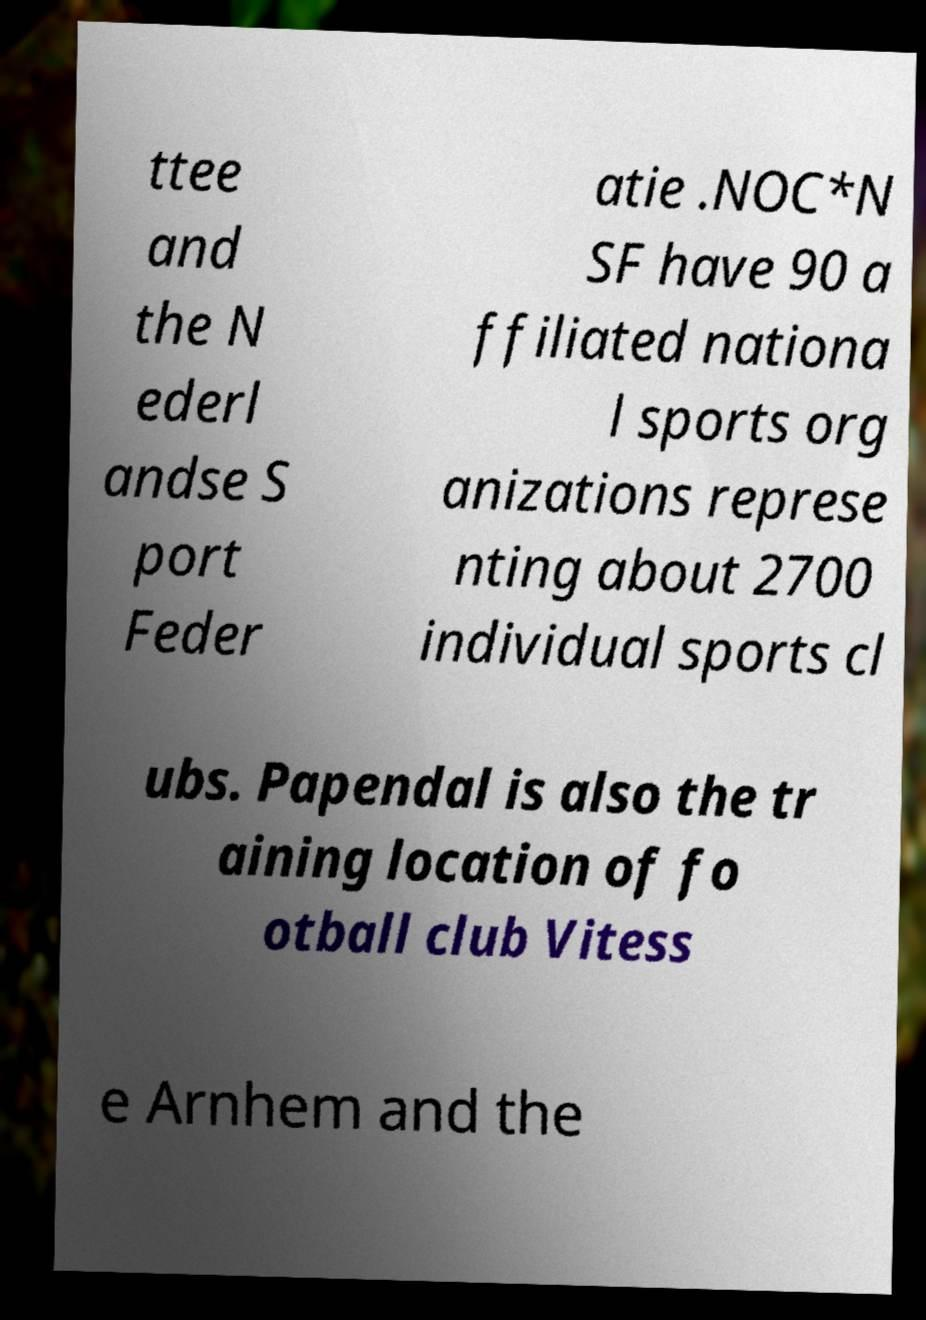There's text embedded in this image that I need extracted. Can you transcribe it verbatim? ttee and the N ederl andse S port Feder atie .NOC*N SF have 90 a ffiliated nationa l sports org anizations represe nting about 2700 individual sports cl ubs. Papendal is also the tr aining location of fo otball club Vitess e Arnhem and the 